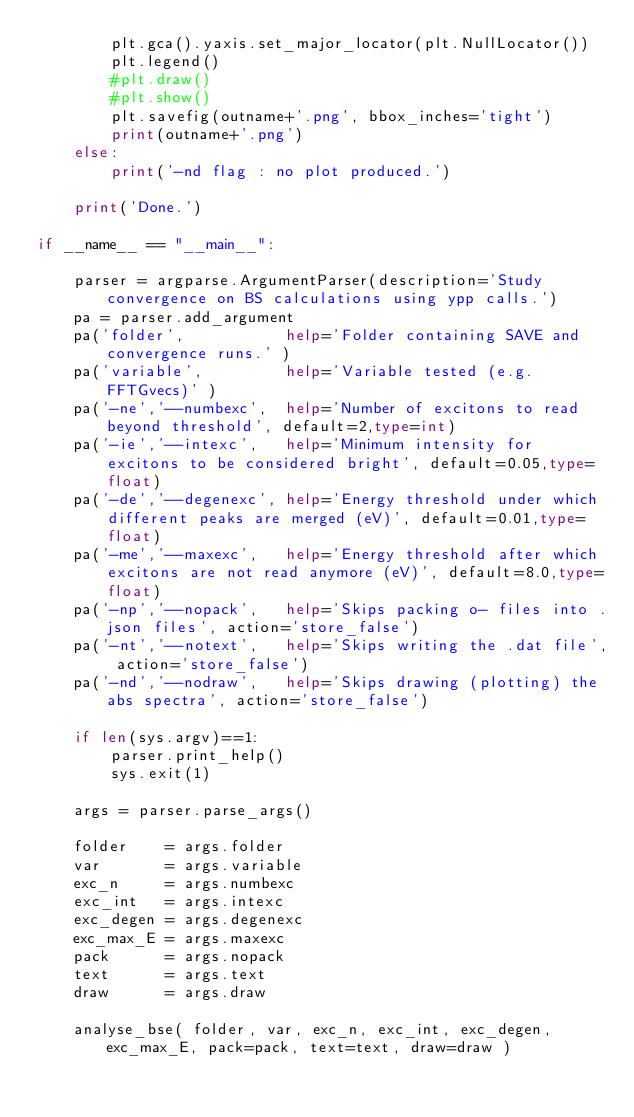<code> <loc_0><loc_0><loc_500><loc_500><_Python_>        plt.gca().yaxis.set_major_locator(plt.NullLocator())
        plt.legend()
        #plt.draw()
        #plt.show()
        plt.savefig(outname+'.png', bbox_inches='tight')
        print(outname+'.png')
    else:
        print('-nd flag : no plot produced.')

    print('Done.')

if __name__ == "__main__":

    parser = argparse.ArgumentParser(description='Study convergence on BS calculations using ypp calls.')
    pa = parser.add_argument
    pa('folder',           help='Folder containing SAVE and convergence runs.' )
    pa('variable',         help='Variable tested (e.g. FFTGvecs)' )
    pa('-ne','--numbexc',  help='Number of excitons to read beyond threshold', default=2,type=int)
    pa('-ie','--intexc',   help='Minimum intensity for excitons to be considered bright', default=0.05,type=float)
    pa('-de','--degenexc', help='Energy threshold under which different peaks are merged (eV)', default=0.01,type=float)
    pa('-me','--maxexc',   help='Energy threshold after which excitons are not read anymore (eV)', default=8.0,type=float)
    pa('-np','--nopack',   help='Skips packing o- files into .json files', action='store_false')
    pa('-nt','--notext',   help='Skips writing the .dat file', action='store_false')
    pa('-nd','--nodraw',   help='Skips drawing (plotting) the abs spectra', action='store_false')

    if len(sys.argv)==1:
        parser.print_help()
        sys.exit(1)

    args = parser.parse_args()

    folder    = args.folder
    var       = args.variable
    exc_n     = args.numbexc
    exc_int   = args.intexc
    exc_degen = args.degenexc
    exc_max_E = args.maxexc
    pack      = args.nopack
    text      = args.text
    draw      = args.draw

    analyse_bse( folder, var, exc_n, exc_int, exc_degen, exc_max_E, pack=pack, text=text, draw=draw )

</code> 